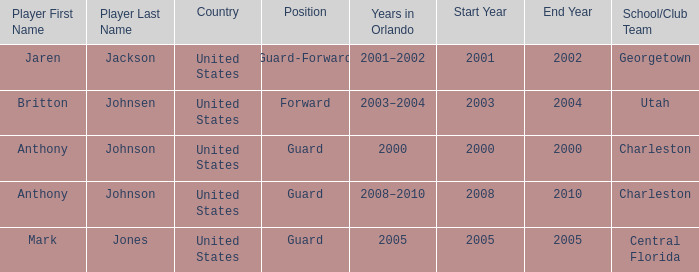Who was the Player that spent the Year 2005 in Orlando? Mark Jones. 